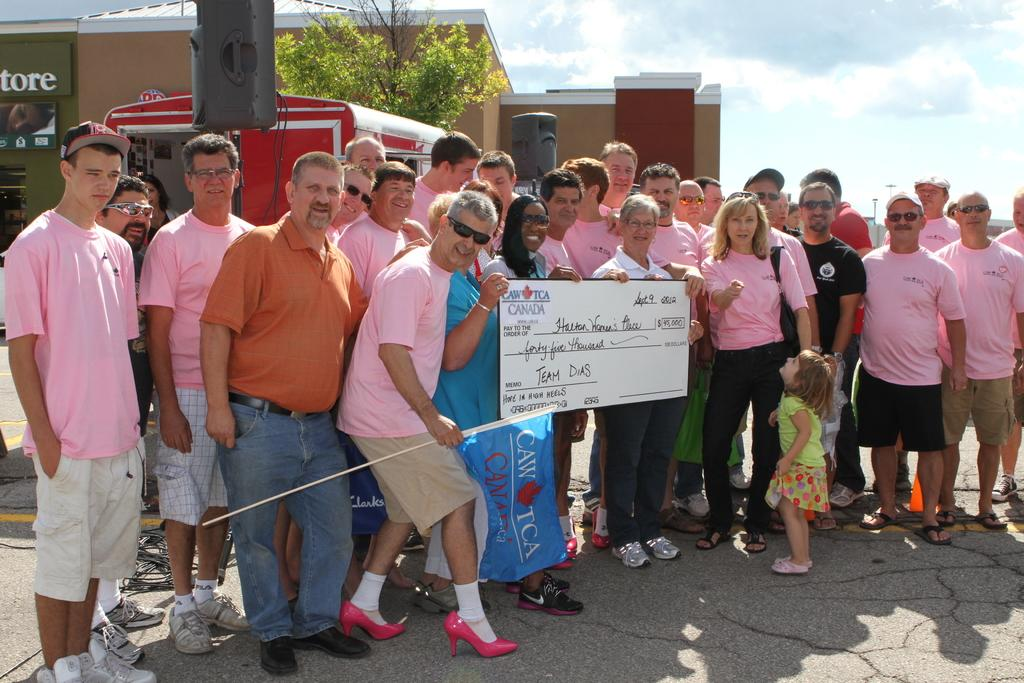What are the people in the image doing? The people in the image are standing on the road and holding a flag and a board. What can be seen in the background of the image? There is a building, a tree, a van, and a pole in the background. What is the condition of the sky in the image? The sky is cloudy in the image. What songs are being sung by the people in the image? There is no indication in the image that the people are singing songs, so it cannot be determined from the picture. What type of competition is taking place in the image? There is no competition present in the image; it simply shows people standing on the road holding a flag and a board. 